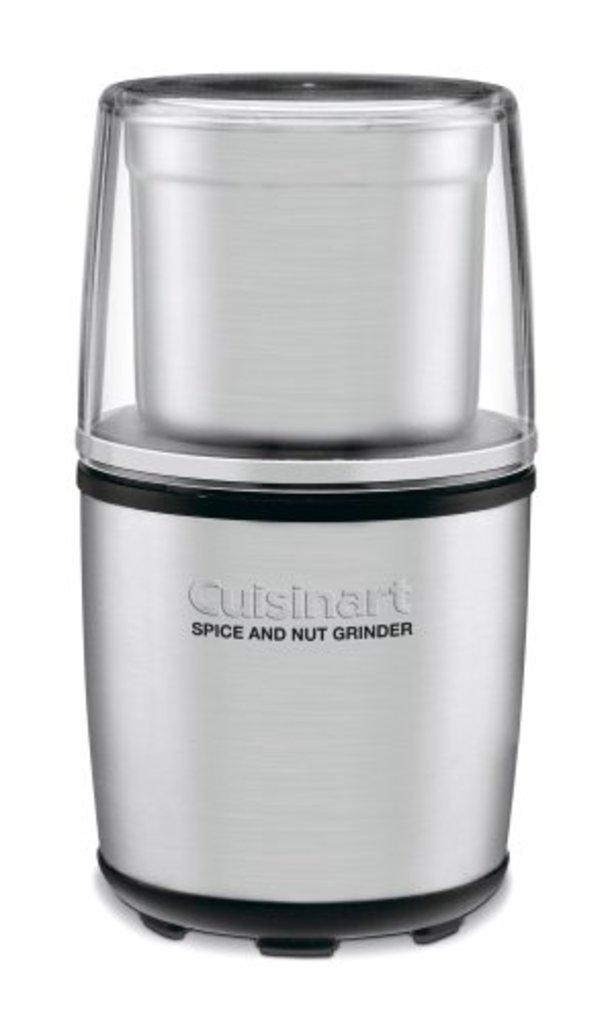What is the machine shown?
Offer a terse response. Spice and nut grinder. What is the brand name of the above machine?
Offer a very short reply. Cuisinart. 